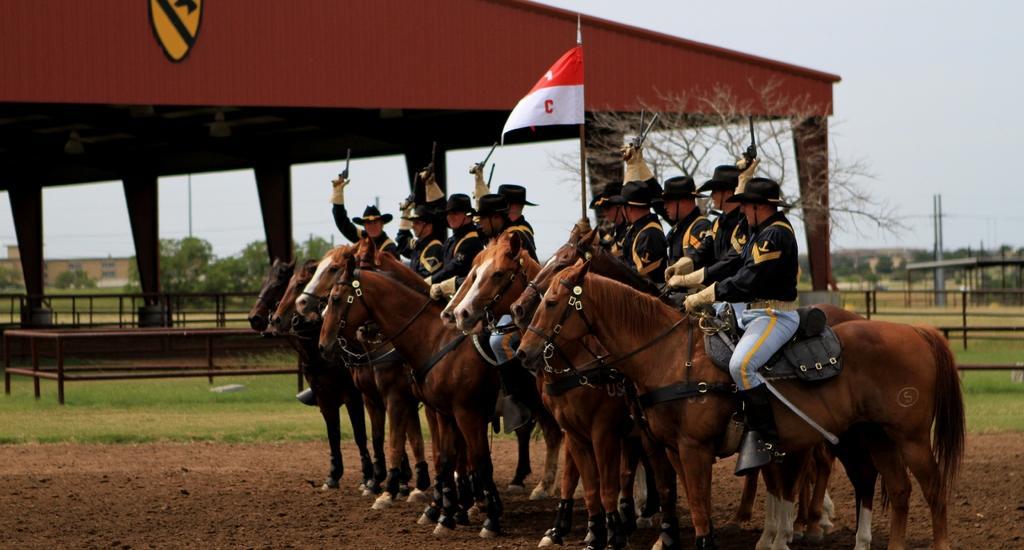Can you describe this image briefly? This image is taken outdoors. At the bottom of the image there is a ground with grass on it. At the top of the image there is a sky. In the background there are many trees and plants and there is a house. There are a few poles. On the left side of the image there is a stable with a roof and walls. There are a few railings. In the middle of the image a few people are sitting on the horses and there is a flag and they are holding guns in their hands. 